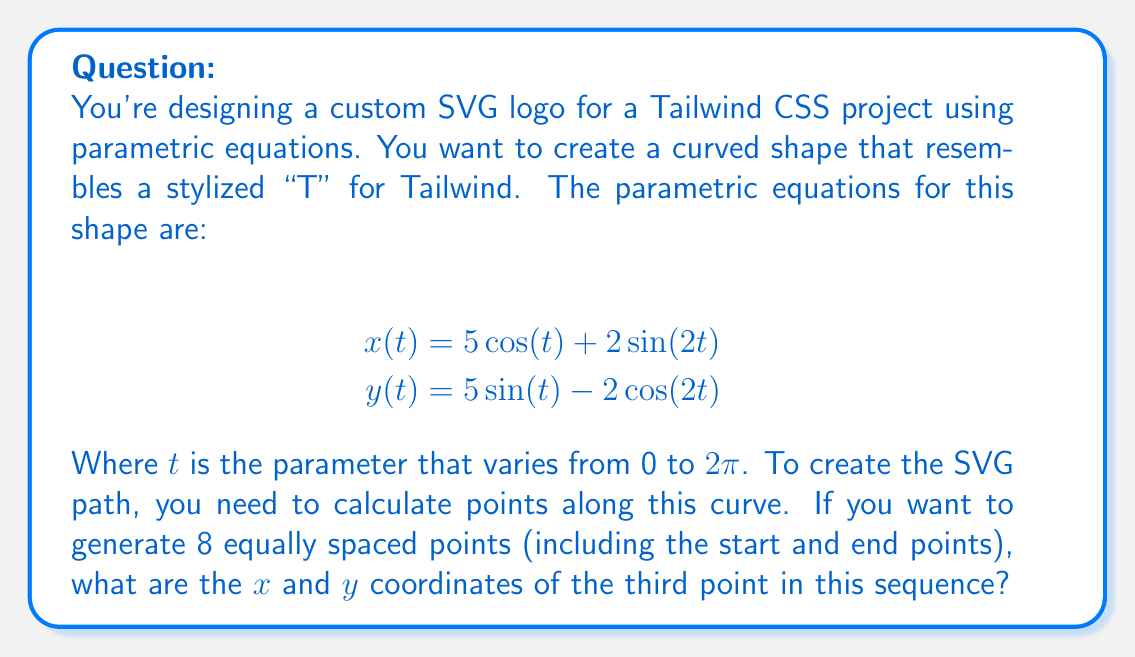What is the answer to this math problem? To solve this problem, we'll follow these steps:

1) First, we need to determine the values of $t$ for our 8 equally spaced points. Since $t$ goes from 0 to $2\pi$, and we want 8 points (7 intervals), each step will be:

   $$\Delta t = \frac{2\pi}{7}$$

2) The values of $t$ for our 8 points will be:
   $$t_k = k \cdot \frac{2\pi}{7}, \text{ where } k = 0, 1, 2, ..., 7$$

3) We're asked about the third point, which corresponds to $k = 2$:

   $$t_2 = 2 \cdot \frac{2\pi}{7} = \frac{4\pi}{7}$$

4) Now we can substitute this value into our parametric equations:

   $$x(\frac{4\pi}{7}) = 5\cos(\frac{4\pi}{7}) + 2\sin(2\cdot\frac{4\pi}{7})$$
   $$y(\frac{4\pi}{7}) = 5\sin(\frac{4\pi}{7}) - 2\cos(2\cdot\frac{4\pi}{7})$$

5) Simplify:
   $$x(\frac{4\pi}{7}) = 5\cos(\frac{4\pi}{7}) + 2\sin(\frac{8\pi}{7})$$
   $$y(\frac{4\pi}{7}) = 5\sin(\frac{4\pi}{7}) - 2\cos(\frac{8\pi}{7})$$

6) Calculate these values (you may use a calculator):
   $$x(\frac{4\pi}{7}) \approx -3.2139$$
   $$y(\frac{4\pi}{7}) \approx 4.6194$$

7) In SVG, we typically round to a few decimal places. Rounding to 2 decimal places:
   $$x \approx -3.21$$
   $$y \approx 4.62$$
Answer: The x and y coordinates of the third point are approximately (-3.21, 4.62). 